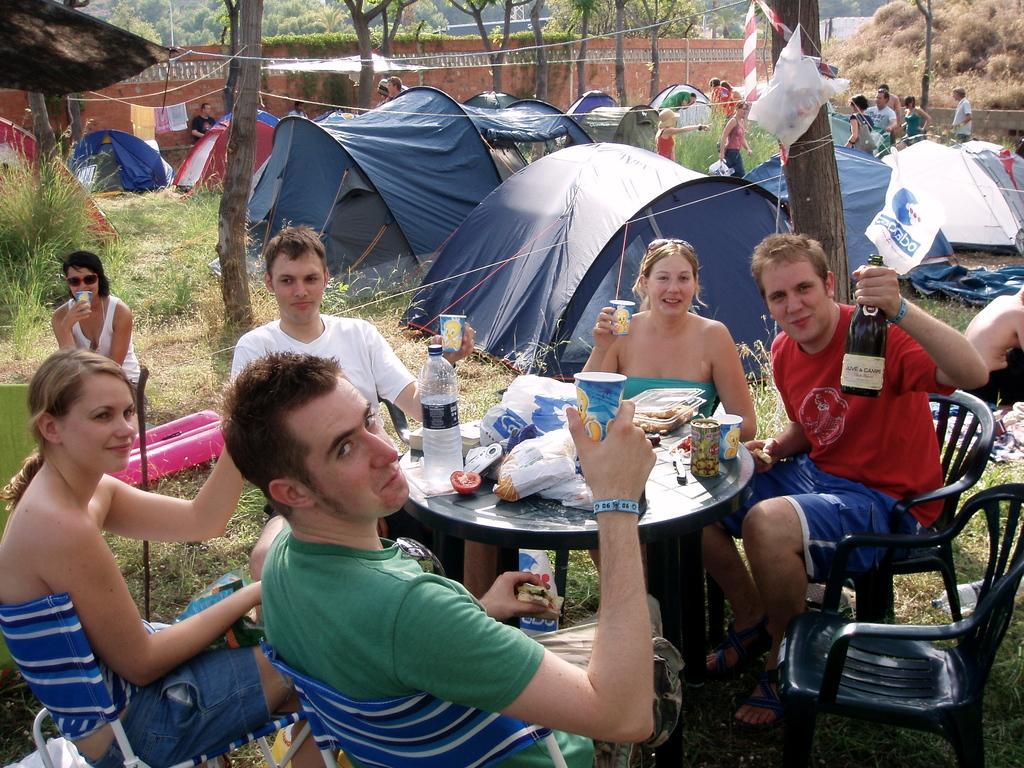Can you describe this image briefly? In this picture there are group of people those who are sitting around the table, table contains different types of food items and water bottle, there are some trees around the area of the image and tents around the area of the image. 